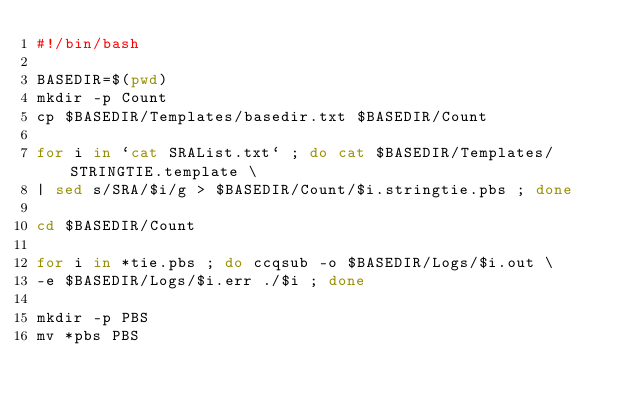<code> <loc_0><loc_0><loc_500><loc_500><_Bash_>#!/bin/bash

BASEDIR=$(pwd)
mkdir -p Count
cp $BASEDIR/Templates/basedir.txt $BASEDIR/Count

for i in `cat SRAList.txt` ; do cat $BASEDIR/Templates/STRINGTIE.template \
| sed s/SRA/$i/g > $BASEDIR/Count/$i.stringtie.pbs ; done

cd $BASEDIR/Count

for i in *tie.pbs ; do ccqsub -o $BASEDIR/Logs/$i.out \
-e $BASEDIR/Logs/$i.err ./$i ; done

mkdir -p PBS
mv *pbs PBS
</code> 